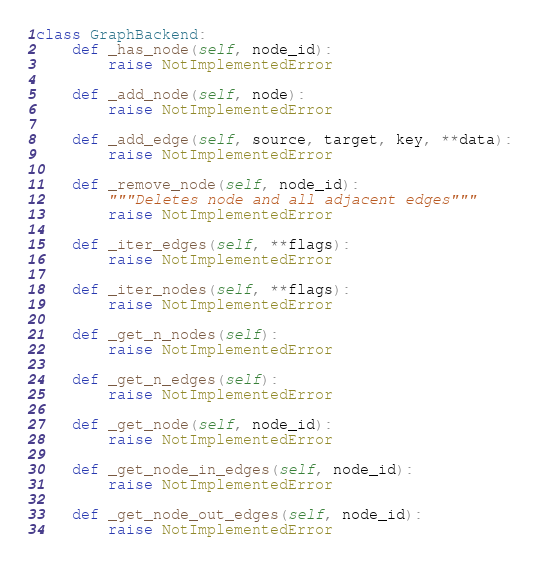<code> <loc_0><loc_0><loc_500><loc_500><_Python_>class GraphBackend:
    def _has_node(self, node_id):
        raise NotImplementedError

    def _add_node(self, node):
        raise NotImplementedError

    def _add_edge(self, source, target, key, **data):
        raise NotImplementedError

    def _remove_node(self, node_id):
        """Deletes node and all adjacent edges"""
        raise NotImplementedError

    def _iter_edges(self, **flags):
        raise NotImplementedError

    def _iter_nodes(self, **flags):
        raise NotImplementedError

    def _get_n_nodes(self):
        raise NotImplementedError

    def _get_n_edges(self):
        raise NotImplementedError

    def _get_node(self, node_id):
        raise NotImplementedError

    def _get_node_in_edges(self, node_id):
        raise NotImplementedError

    def _get_node_out_edges(self, node_id):
        raise NotImplementedError
</code> 